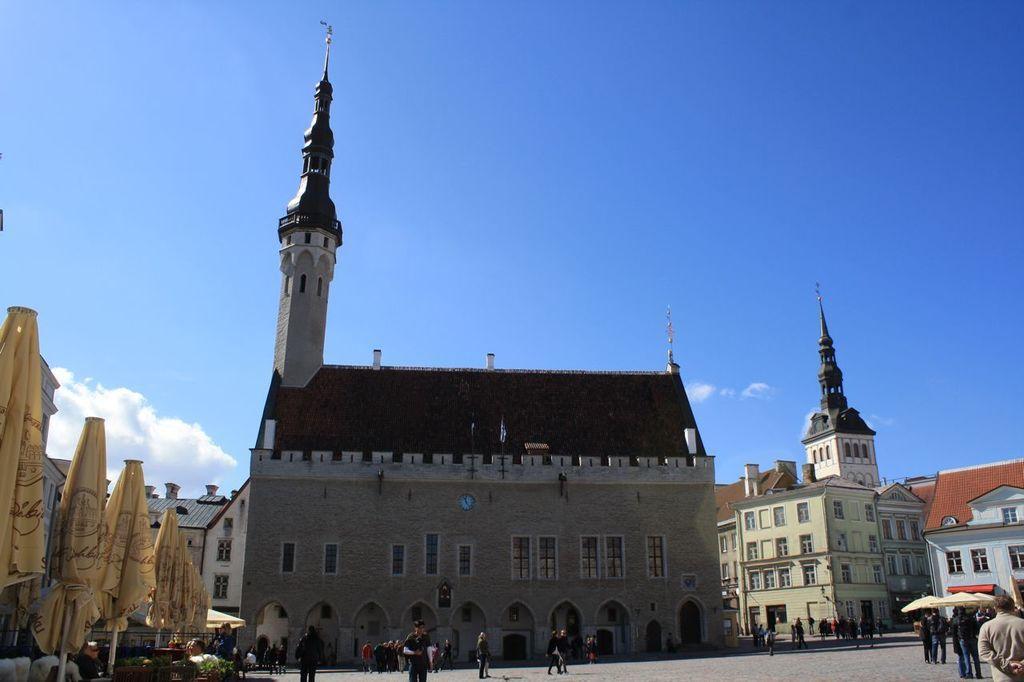In one or two sentences, can you explain what this image depicts? At the bottom we can see few persons are standing and few persons are walking on the ground. On the left and write we can see tents and poles. In the background we can see buildings,windows,house plants and clouds in the sky. 